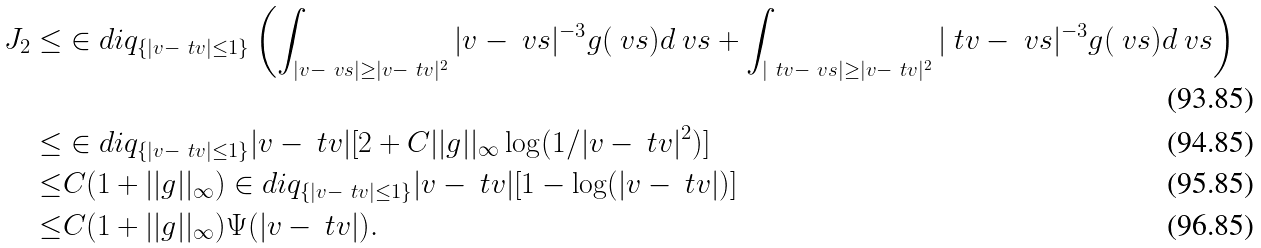Convert formula to latex. <formula><loc_0><loc_0><loc_500><loc_500>J _ { 2 } \leq & \in d i q _ { \{ | v - \ t v | \leq 1 \} } \left ( \int _ { | v - \ v s | \geq | v - \ t v | ^ { 2 } } | v - \ v s | ^ { - 3 } g ( \ v s ) d \ v s + \int _ { | \ t v - \ v s | \geq | v - \ t v | ^ { 2 } } | \ t v - \ v s | ^ { - 3 } g ( \ v s ) d \ v s \right ) \\ \leq & \in d i q _ { \{ | v - \ t v | \leq 1 \} } | v - \ t v | [ 2 + C | | g | | _ { \infty } \log ( 1 / | v - \ t v | ^ { 2 } ) ] \\ \leq & C ( 1 + | | g | | _ { \infty } ) \in d i q _ { \{ | v - \ t v | \leq 1 \} } | v - \ t v | [ 1 - \log ( | v - \ t v | ) ] \\ \leq & C ( 1 + | | g | | _ { \infty } ) \Psi ( | v - \ t v | ) .</formula> 